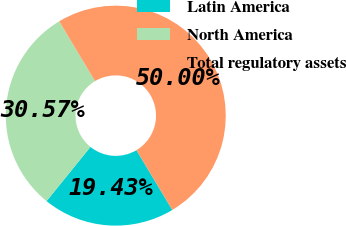Convert chart to OTSL. <chart><loc_0><loc_0><loc_500><loc_500><pie_chart><fcel>Latin America<fcel>North America<fcel>Total regulatory assets<nl><fcel>19.43%<fcel>30.57%<fcel>50.0%<nl></chart> 